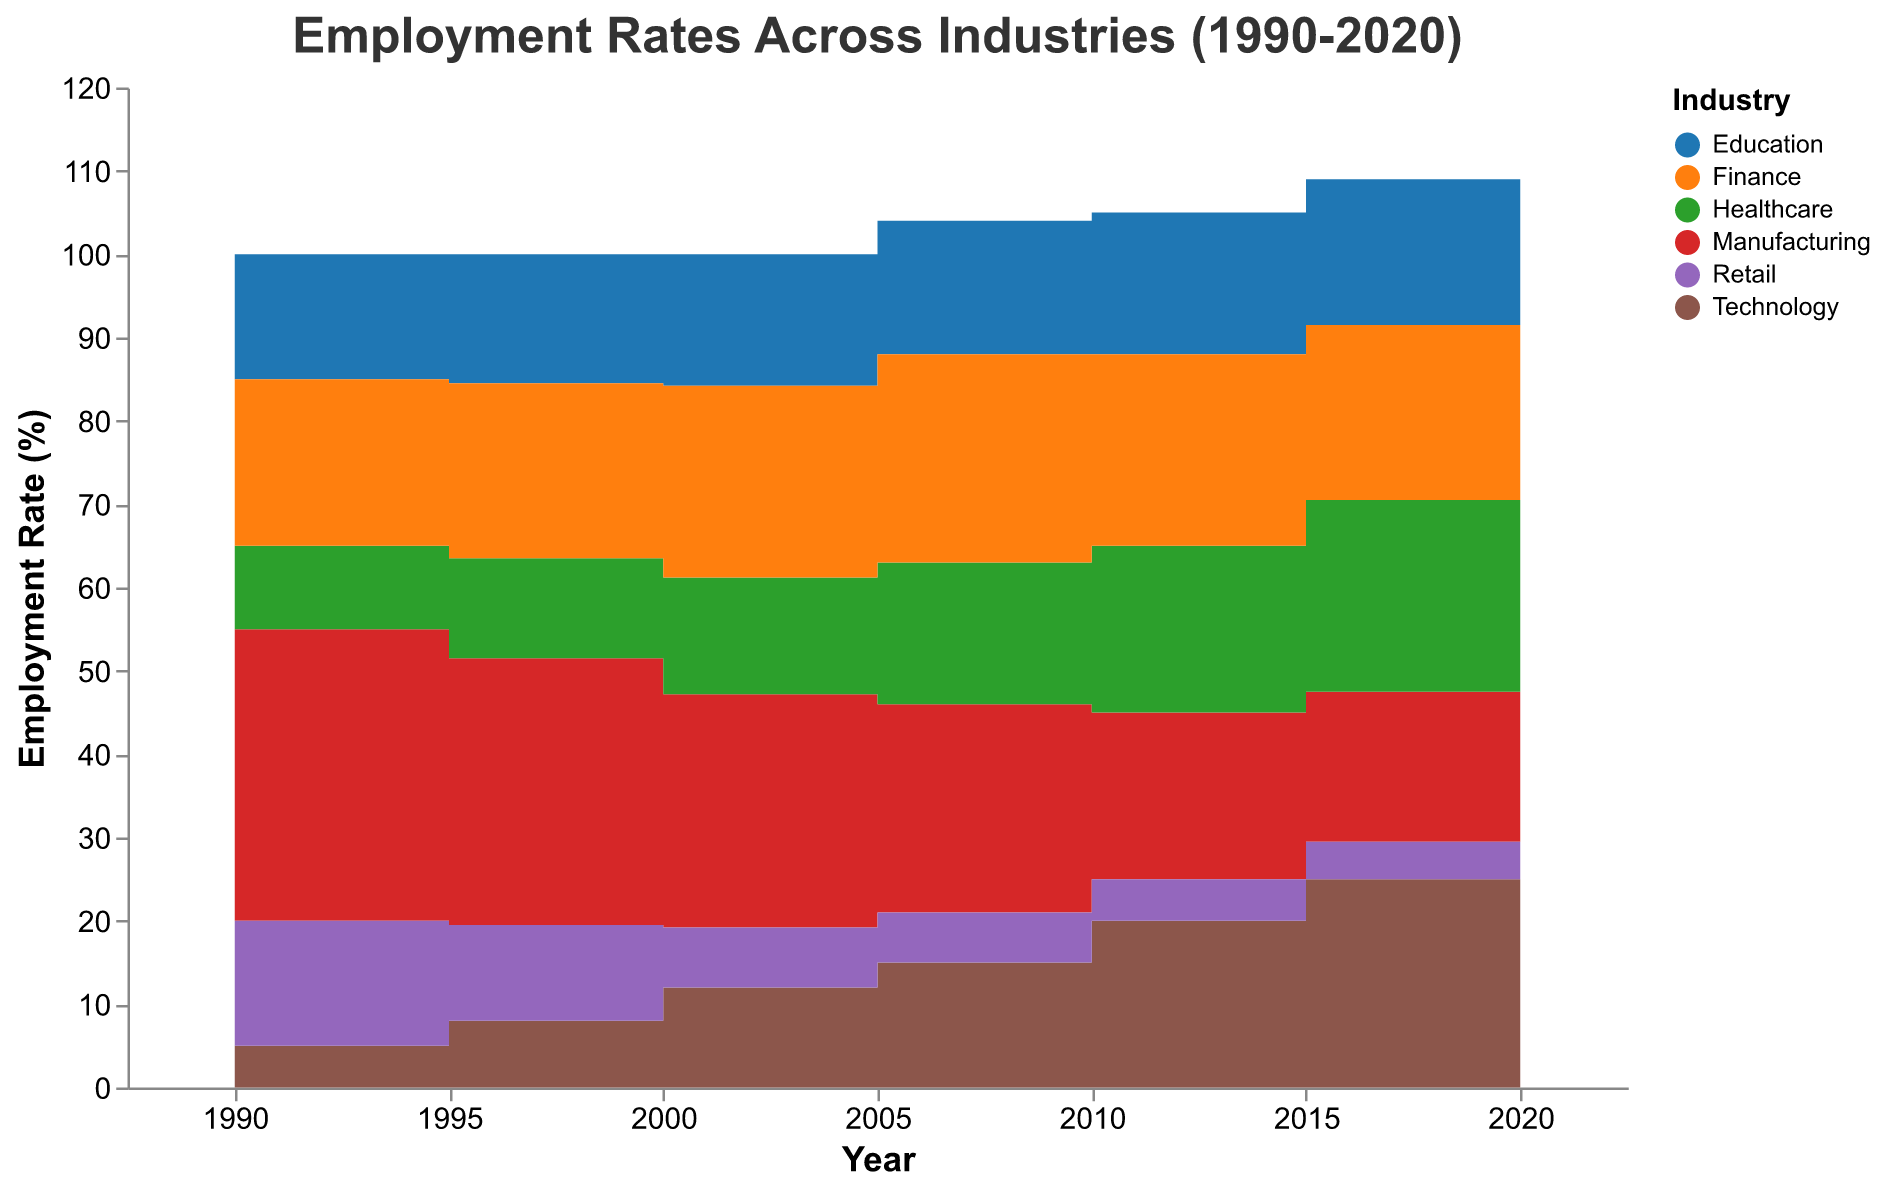What is the title of the figure? The title is displayed at the top of the chart in a larger and bold font. It summarizes what the chart is about and provides context for the rest of the data.
Answer: "Employment Rates Across Industries (1990-2020)" How does the employment rate in Manufacturing change from 1990 to 2020? Track the Manufacturing line across the x-axis from 1990 to 2020. Notice the starting point at 35.0% in 1990 and ending at 15.0% in 2020. The rate decreases over each plotted year.
Answer: It decreases from 35.0% to 15.0% Which industry has the highest employment rate in 2020? Look at the employment rates for all industries in the segment of 2020. The highest colored area at this year marks the highest employment rate.
Answer: Technology Between which years does the Healthcare industry see the greatest increase in employment rate? Check the Healthcare line and identify the greatest change in height between two consecutive years. Calculate the differences: 1990-1995 (+2%), 1995-2000 (+2%), 2000-2005 (+3%), 2005-2010 (+3%), 2010-2015 (+3%), 2015-2020 (+2%). The 2000 to 2005 period has the greatest increase.
Answer: 2000 to 2005 Compare the employment rates of Technology and Retail in 1990 and 2020. Which industry shows a greater absolute increase? Identify the employment rates in 1990 and 2020 for both industries: Technology: 5.0% to 30.0%, Retail: 15.0% to 4.0%. Compute absolute increases: Technology (+25%), Retail (-11%). Technology shows a greater absolute increase.
Answer: Technology What is the employment rate of the Finance industry in 2015, and has it increased or decreased by 2020? Locate the Finance line and note the employment rate at 2015 (21.0%). Then check the rate at 2020 (19.0%). The rate has decreased.
Answer: 21.0%, decreased Which industry has the most stable employment rate between 1990 and 2020? Examine each industry's line for fluctuations. The Education line shows the least change with its values remaining between 15.0% (1990) and 18.0% (2020).
Answer: Education What is the percentage point difference in Healthcare employment rate between 2015 and 2020? Identify the employment rate of Healthcare in 2015 (23.0%) and 2020 (25.0%). Compute the difference: 25.0% - 23.0% = 2.0 percentage points.
Answer: 2.0 percentage points During which year range does the Manufacturing industry drop below 20% in employment rate? Check the Manufacturing line for when it crosses below the 20% mark. It drops below in the segment between 2005 and 2010 where it goes from 25.0% to 20.0%.
Answer: 2005 to 2010 